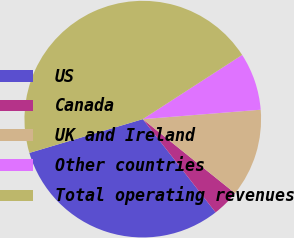Convert chart. <chart><loc_0><loc_0><loc_500><loc_500><pie_chart><fcel>US<fcel>Canada<fcel>UK and Ireland<fcel>Other countries<fcel>Total operating revenues<nl><fcel>30.95%<fcel>3.68%<fcel>12.04%<fcel>7.86%<fcel>45.48%<nl></chart> 